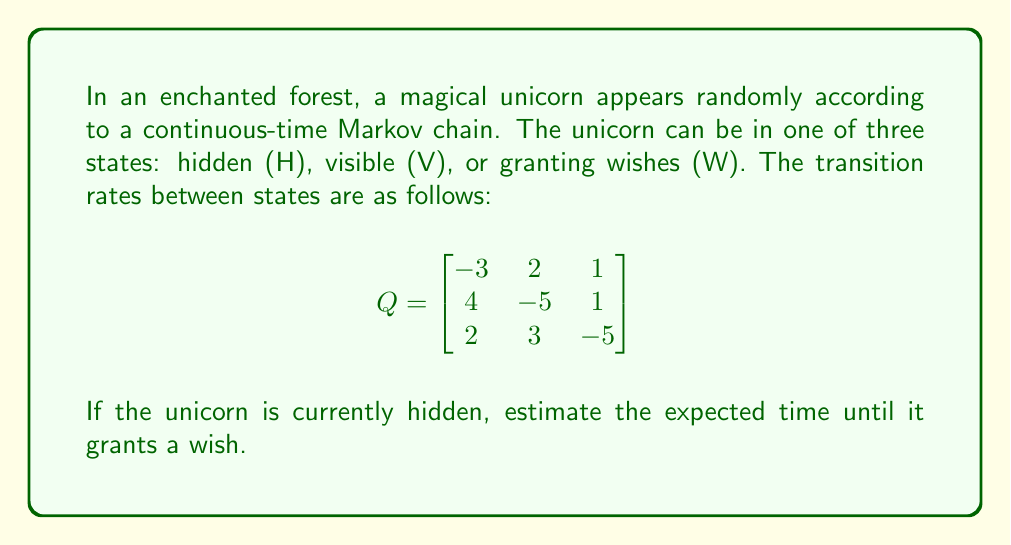Show me your answer to this math problem. To solve this problem, we'll use the first passage time calculations for continuous-time Markov chains.

Step 1: Identify the initial and target states
Initial state: Hidden (H)
Target state: Granting wishes (W)

Step 2: Set up the system of linear equations
Let $m_i$ be the expected time to reach state W from state i. We need to find $m_H$.

The system of equations is:
$$
\begin{aligned}
m_H &= \frac{1}{3} + \frac{2}{3}m_V + \frac{1}{3}m_W \\
m_V &= \frac{1}{5} + \frac{4}{5}m_H + \frac{1}{5}m_W \\
m_W &= 0
\end{aligned}
$$

Step 3: Simplify the equations
Substitute $m_W = 0$ into the first two equations:
$$
\begin{aligned}
m_H &= \frac{1}{3} + \frac{2}{3}m_V \\
m_V &= \frac{1}{5} + \frac{4}{5}m_H
\end{aligned}
$$

Step 4: Solve the system of equations
Substitute the second equation into the first:
$$
\begin{aligned}
m_H &= \frac{1}{3} + \frac{2}{3}(\frac{1}{5} + \frac{4}{5}m_H) \\
m_H &= \frac{1}{3} + \frac{2}{15} + \frac{8}{15}m_H \\
\frac{7}{15}m_H &= \frac{1}{3} + \frac{2}{15} \\
m_H &= \frac{15}{7}(\frac{1}{3} + \frac{2}{15}) \\
m_H &= \frac{15}{7} \cdot \frac{7}{15} = 1
\end{aligned}
$$

Therefore, the expected time until the unicorn grants a wish, starting from the hidden state, is 1 time unit.
Answer: 1 time unit 